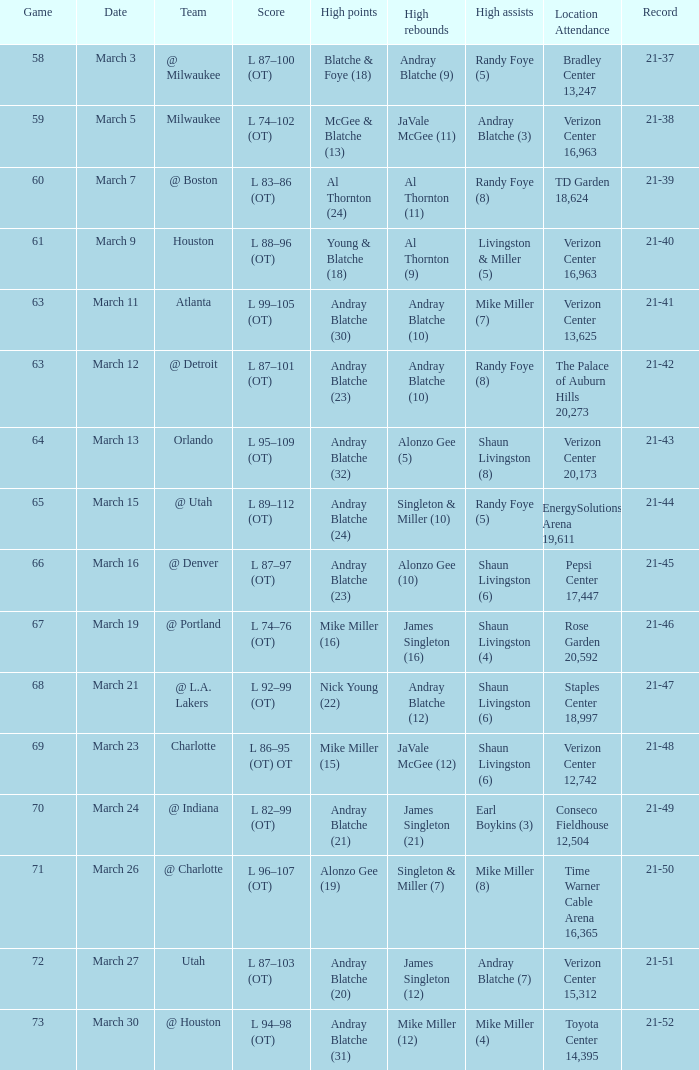What date had the attendance of 18,624 at td garden? March 7. Can you give me this table as a dict? {'header': ['Game', 'Date', 'Team', 'Score', 'High points', 'High rebounds', 'High assists', 'Location Attendance', 'Record'], 'rows': [['58', 'March 3', '@ Milwaukee', 'L 87–100 (OT)', 'Blatche & Foye (18)', 'Andray Blatche (9)', 'Randy Foye (5)', 'Bradley Center 13,247', '21-37'], ['59', 'March 5', 'Milwaukee', 'L 74–102 (OT)', 'McGee & Blatche (13)', 'JaVale McGee (11)', 'Andray Blatche (3)', 'Verizon Center 16,963', '21-38'], ['60', 'March 7', '@ Boston', 'L 83–86 (OT)', 'Al Thornton (24)', 'Al Thornton (11)', 'Randy Foye (8)', 'TD Garden 18,624', '21-39'], ['61', 'March 9', 'Houston', 'L 88–96 (OT)', 'Young & Blatche (18)', 'Al Thornton (9)', 'Livingston & Miller (5)', 'Verizon Center 16,963', '21-40'], ['63', 'March 11', 'Atlanta', 'L 99–105 (OT)', 'Andray Blatche (30)', 'Andray Blatche (10)', 'Mike Miller (7)', 'Verizon Center 13,625', '21-41'], ['63', 'March 12', '@ Detroit', 'L 87–101 (OT)', 'Andray Blatche (23)', 'Andray Blatche (10)', 'Randy Foye (8)', 'The Palace of Auburn Hills 20,273', '21-42'], ['64', 'March 13', 'Orlando', 'L 95–109 (OT)', 'Andray Blatche (32)', 'Alonzo Gee (5)', 'Shaun Livingston (8)', 'Verizon Center 20,173', '21-43'], ['65', 'March 15', '@ Utah', 'L 89–112 (OT)', 'Andray Blatche (24)', 'Singleton & Miller (10)', 'Randy Foye (5)', 'EnergySolutions Arena 19,611', '21-44'], ['66', 'March 16', '@ Denver', 'L 87–97 (OT)', 'Andray Blatche (23)', 'Alonzo Gee (10)', 'Shaun Livingston (6)', 'Pepsi Center 17,447', '21-45'], ['67', 'March 19', '@ Portland', 'L 74–76 (OT)', 'Mike Miller (16)', 'James Singleton (16)', 'Shaun Livingston (4)', 'Rose Garden 20,592', '21-46'], ['68', 'March 21', '@ L.A. Lakers', 'L 92–99 (OT)', 'Nick Young (22)', 'Andray Blatche (12)', 'Shaun Livingston (6)', 'Staples Center 18,997', '21-47'], ['69', 'March 23', 'Charlotte', 'L 86–95 (OT) OT', 'Mike Miller (15)', 'JaVale McGee (12)', 'Shaun Livingston (6)', 'Verizon Center 12,742', '21-48'], ['70', 'March 24', '@ Indiana', 'L 82–99 (OT)', 'Andray Blatche (21)', 'James Singleton (21)', 'Earl Boykins (3)', 'Conseco Fieldhouse 12,504', '21-49'], ['71', 'March 26', '@ Charlotte', 'L 96–107 (OT)', 'Alonzo Gee (19)', 'Singleton & Miller (7)', 'Mike Miller (8)', 'Time Warner Cable Arena 16,365', '21-50'], ['72', 'March 27', 'Utah', 'L 87–103 (OT)', 'Andray Blatche (20)', 'James Singleton (12)', 'Andray Blatche (7)', 'Verizon Center 15,312', '21-51'], ['73', 'March 30', '@ Houston', 'L 94–98 (OT)', 'Andray Blatche (31)', 'Mike Miller (12)', 'Mike Miller (4)', 'Toyota Center 14,395', '21-52']]} 